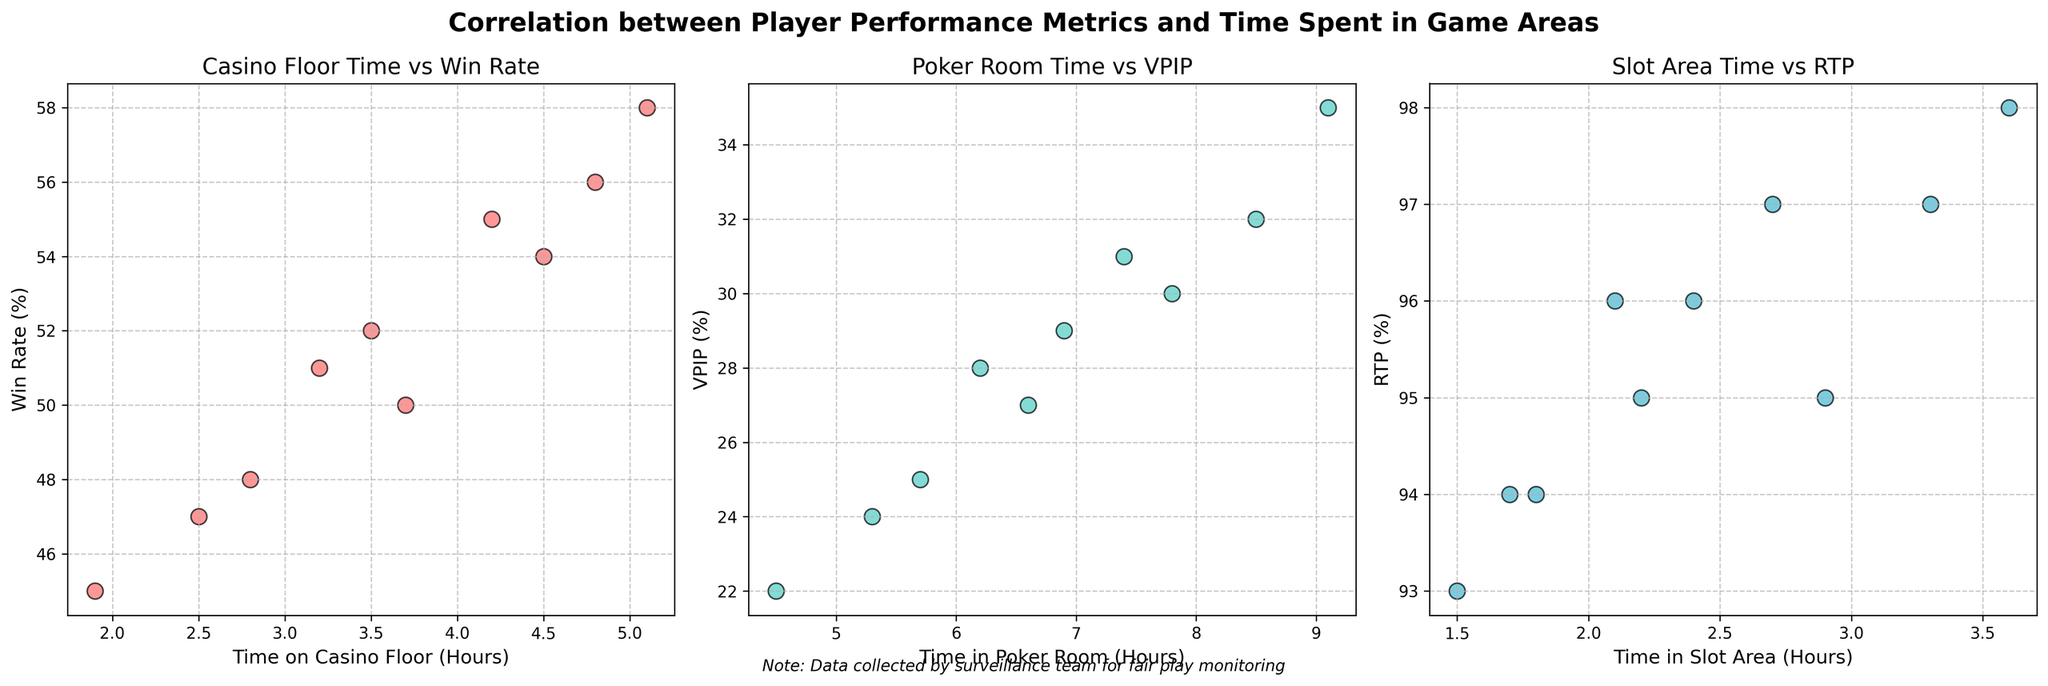What is the title of the entire subplot? The title is usually placed at the top of the subplot. In this figure, it reads "Correlation between Player Performance Metrics and Time Spent in Game Areas".
Answer: Correlation between Player Performance Metrics and Time Spent in Game Areas What color is used for data points in the 'Slot Area Time vs RTP' scatter plot? The color used for each scatter plot can be identified through visual inspection. The 'Slot Area Time vs RTP' scatter plot uses a shade of blue.
Answer: Blue Which scatter plot examines the relationship between Time on Casino Floor and Win Rate? Each scatter plot has a title that specifies the relationship being examined. According to the titles, the first scatter plot from the left examines the relationship between "Time on Casino Floor (Hours)" and "Win Rate (%)".
Answer: The first scatter plot What is the range of the Time in Poker Room for the players shown in the Poker Room Time vs VPIP scatter plot? Inspecting the x-axis of the 'Poker Room Time vs VPIP' scatter plot, we notice that the values range from approximately 4 to 9 hours.
Answer: 4 to 9 hours How many players have a Win Rate above 50%? We need to count the data points in the 'Casino Floor Time vs Win Rate' scatter plot that have a y-value (Win Rate) above 50%. There are six players (John_Smith, Michael_Brown, David_Wilson, Jennifer_Martinez, William_Thompson, and Olivia_Garcia) who meet this criterion.
Answer: 6 Which player has the highest RTP (Return to Player) and how much time do they spend in the Slot Area? Referring to the third scatter plot and identifying the highest y-value (RTP), we see Jennifer_Martinez has the highest RTP at 98%. Jennifer spends 3.6 hours in the Slot Area.
Answer: Jennifer_Martinez, 3.6 hours Is there a positive correlation between 'Time in Poker Room' and 'VPIP'? We observe the 'Poker Room Time vs VPIP' scatter plot to see if the points trend upwards. The trend appears to be generally positive, indicating a positive correlation.
Answer: Yes What's the average Win Rate for players who spend more than 4 hours on the casino floor? Identify players spending more than 4 hours on the casino floor (David_Wilson, Jennifer_Martinez, Olivia_Garcia, Michael_Brown). Their Win Rates are 58%, 56%, 54%, and 55%. The average is (58+56+54+55) / 4 = 55.75%
Answer: 55.75% Which area (Casino Floor, Poker Room, or Slot Area) shows the most variance in time spent by players? Comparing the spread of data points on the x-axes of each subplot, the Poker Room scatter plot shows the widest range between minimum and maximum values, indicating the most variance.
Answer: Poker Room Do players with higher VPIP percentages tend to spend more or less time in the Poker Room? By inspecting the scatter plot for 'Poker Room Time vs VPIP', it's apparent that players with higher VPIP percentages tend to spend more time in the Poker Room as the points with higher y-values are seen towards the right.
Answer: More time 